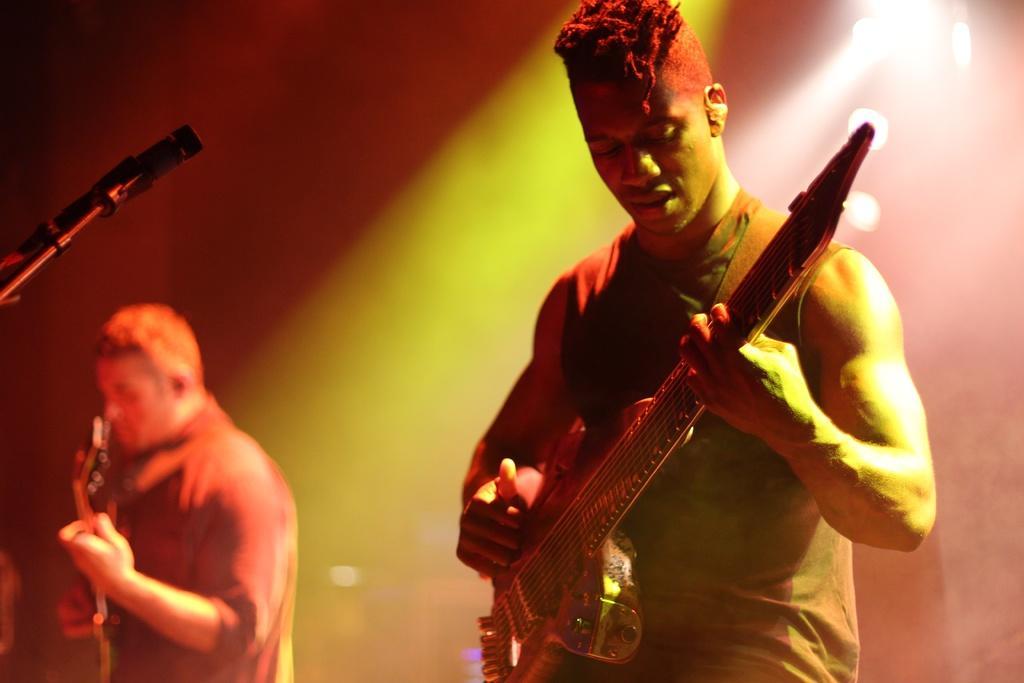Could you give a brief overview of what you see in this image? This picture shows two men standing and playing guitar holding in their hands and we see a microphone in front of them 